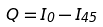<formula> <loc_0><loc_0><loc_500><loc_500>Q = I _ { 0 } - I _ { 4 5 }</formula> 